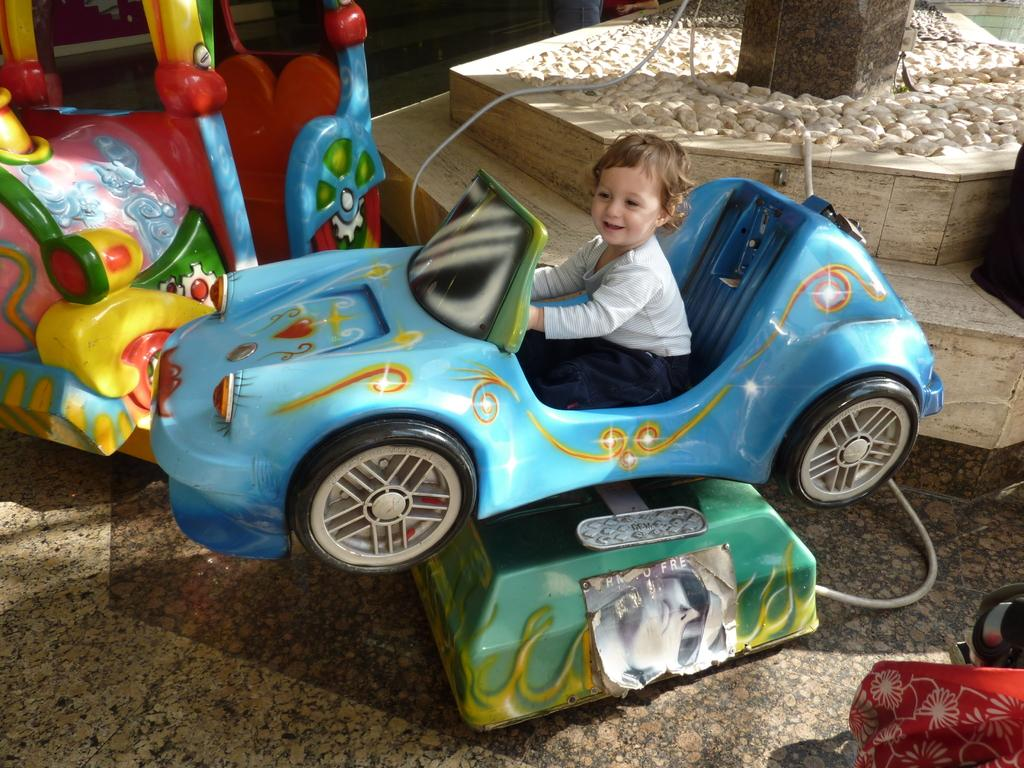What is the main subject in the foreground of the picture? There is a kid in the foreground of the picture. What is the kid sitting on? The kid is sitting on a toy car. What can be seen in the background of the picture? There are toy cars, a pillar, and stones in the background of the picture. What type of crayon is the kid using to draw on the pillar in the image? There is no crayon or drawing activity present in the image. 